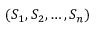Convert formula to latex. <formula><loc_0><loc_0><loc_500><loc_500>( S _ { 1 } , S _ { 2 } , \dots , S _ { n } )</formula> 